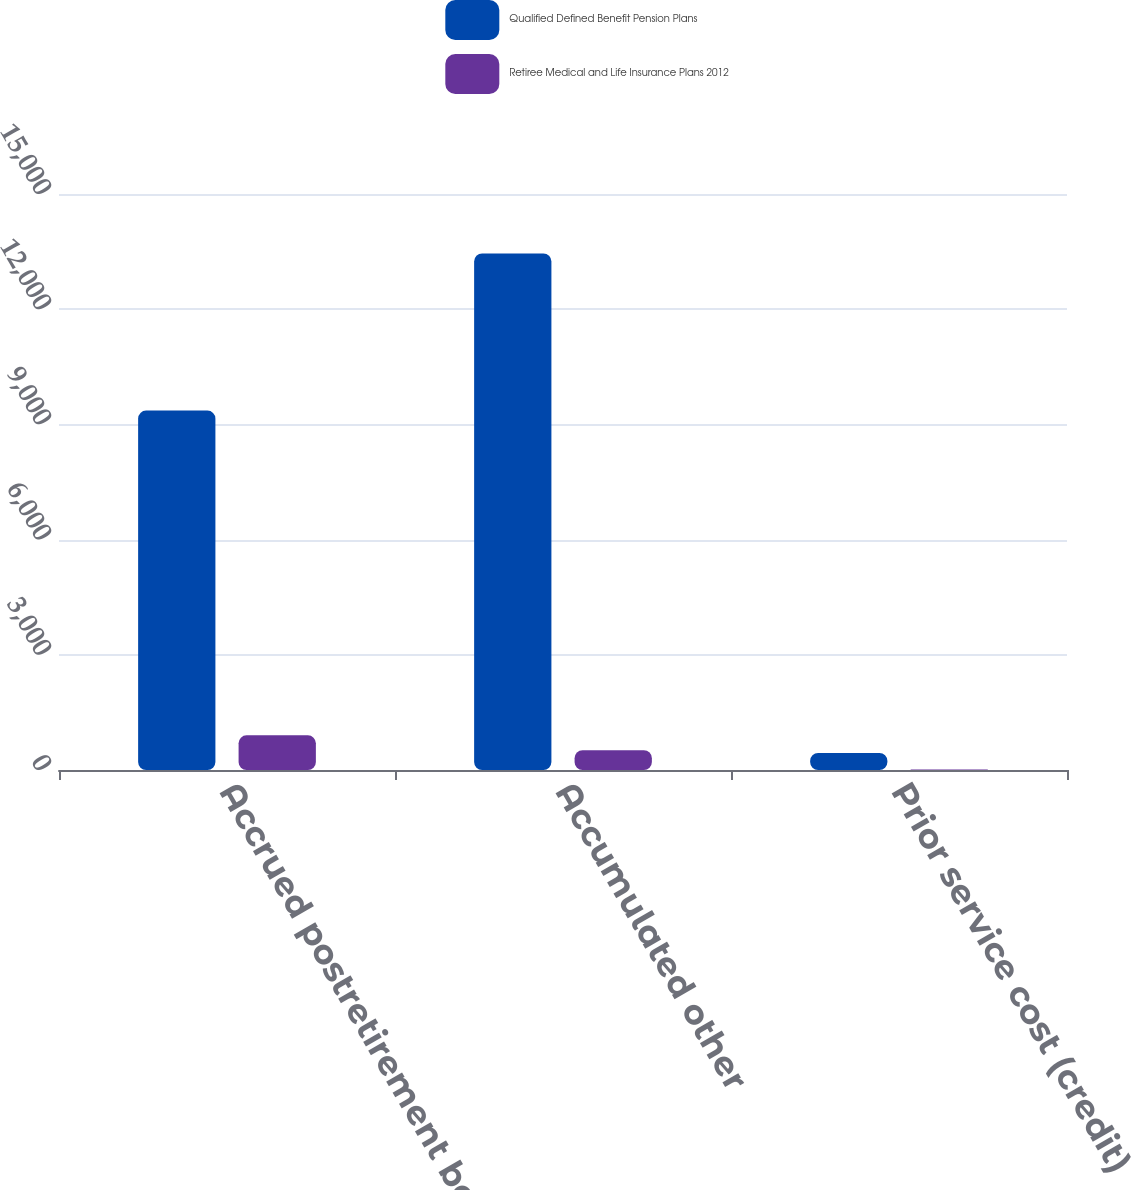Convert chart to OTSL. <chart><loc_0><loc_0><loc_500><loc_500><stacked_bar_chart><ecel><fcel>Accrued postretirement benefit<fcel>Accumulated other<fcel>Prior service cost (credit)<nl><fcel>Qualified Defined Benefit Pension Plans<fcel>9361<fcel>13453<fcel>443<nl><fcel>Retiree Medical and Life Insurance Plans 2012<fcel>902<fcel>516<fcel>13<nl></chart> 